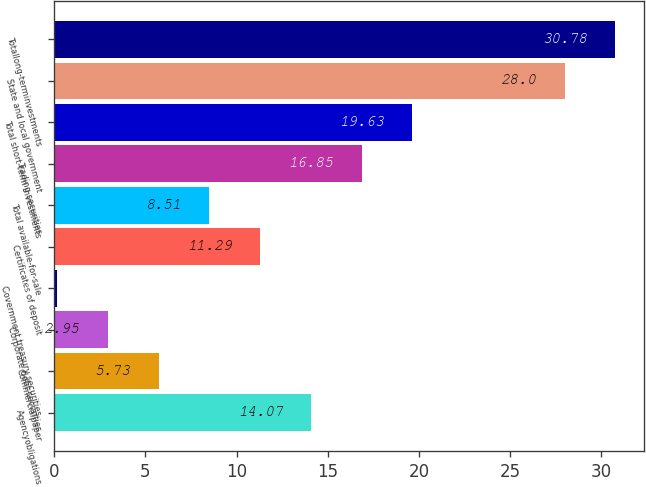Convert chart. <chart><loc_0><loc_0><loc_500><loc_500><bar_chart><fcel>Agencyobligations<fcel>Commercialpaper<fcel>Corporate debt securities<fcel>Government treasury securities<fcel>Certificates of deposit<fcel>Total available-for-sale<fcel>Trading securities<fcel>Total short-term investments<fcel>State and local government<fcel>Totallong-terminvestments<nl><fcel>14.07<fcel>5.73<fcel>2.95<fcel>0.17<fcel>11.29<fcel>8.51<fcel>16.85<fcel>19.63<fcel>28<fcel>30.78<nl></chart> 